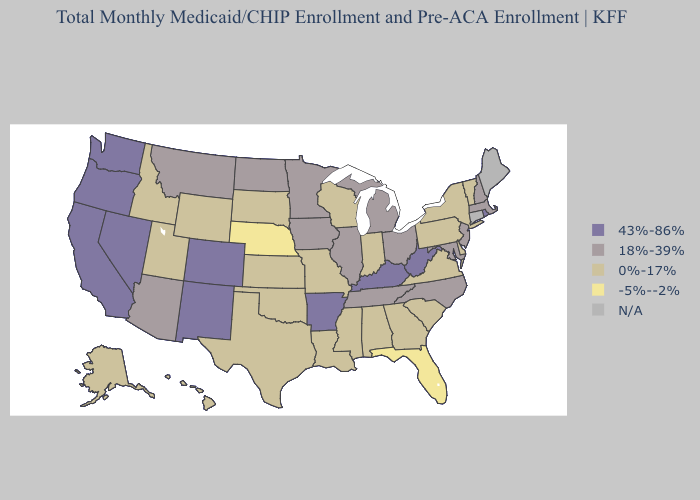What is the value of New Mexico?
Concise answer only. 43%-86%. Does Tennessee have the lowest value in the South?
Write a very short answer. No. Name the states that have a value in the range 43%-86%?
Concise answer only. Arkansas, California, Colorado, Kentucky, Nevada, New Mexico, Oregon, Rhode Island, Washington, West Virginia. Which states have the lowest value in the Northeast?
Write a very short answer. New York, Pennsylvania, Vermont. Name the states that have a value in the range 43%-86%?
Quick response, please. Arkansas, California, Colorado, Kentucky, Nevada, New Mexico, Oregon, Rhode Island, Washington, West Virginia. How many symbols are there in the legend?
Concise answer only. 5. What is the value of North Dakota?
Quick response, please. 18%-39%. Name the states that have a value in the range N/A?
Keep it brief. Connecticut, Maine. Among the states that border Nebraska , does Wyoming have the highest value?
Answer briefly. No. What is the value of Hawaii?
Answer briefly. 0%-17%. Does Minnesota have the highest value in the MidWest?
Short answer required. Yes. 